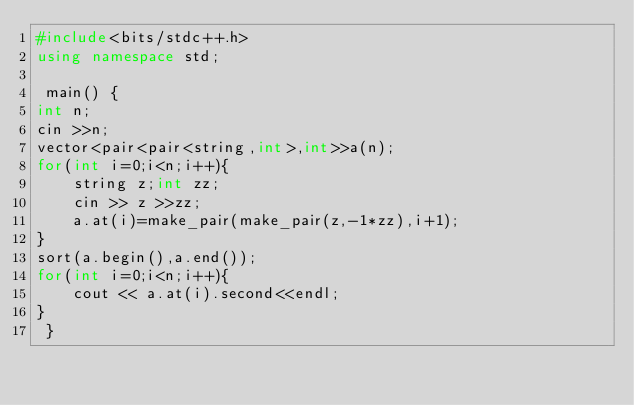<code> <loc_0><loc_0><loc_500><loc_500><_C++_>#include<bits/stdc++.h>
using namespace std;

 main() {
int n;
cin >>n;
vector<pair<pair<string,int>,int>>a(n);
for(int i=0;i<n;i++){
    string z;int zz;
    cin >> z >>zz;
    a.at(i)=make_pair(make_pair(z,-1*zz),i+1);
}
sort(a.begin(),a.end());
for(int i=0;i<n;i++){
    cout << a.at(i).second<<endl;
}
 }


</code> 